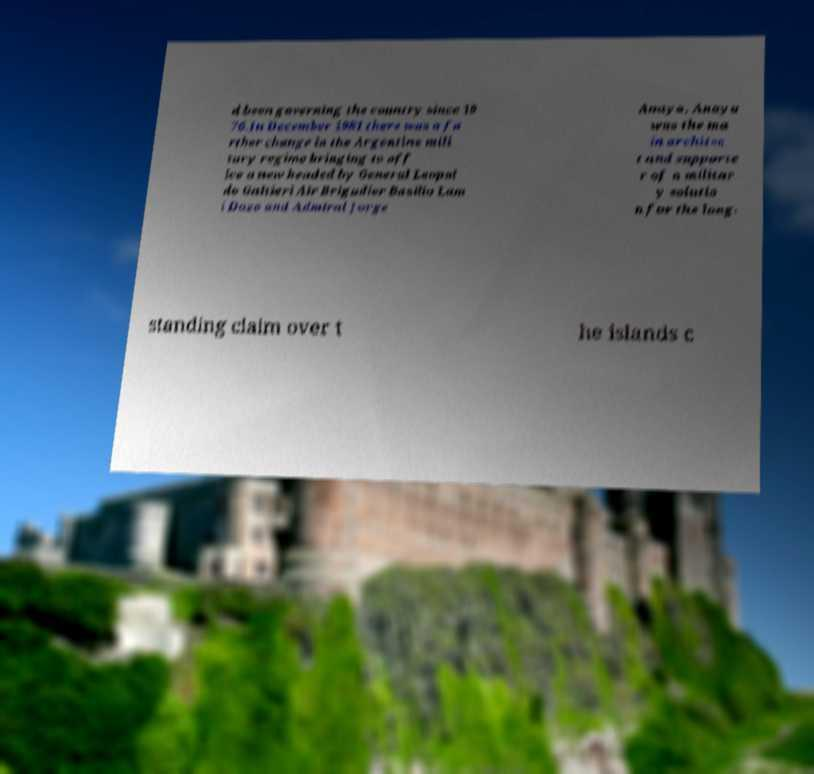Can you read and provide the text displayed in the image?This photo seems to have some interesting text. Can you extract and type it out for me? d been governing the country since 19 76.In December 1981 there was a fu rther change in the Argentine mili tary regime bringing to off ice a new headed by General Leopol do Galtieri Air Brigadier Basilio Lam i Dozo and Admiral Jorge Anaya. Anaya was the ma in architec t and supporte r of a militar y solutio n for the long- standing claim over t he islands c 